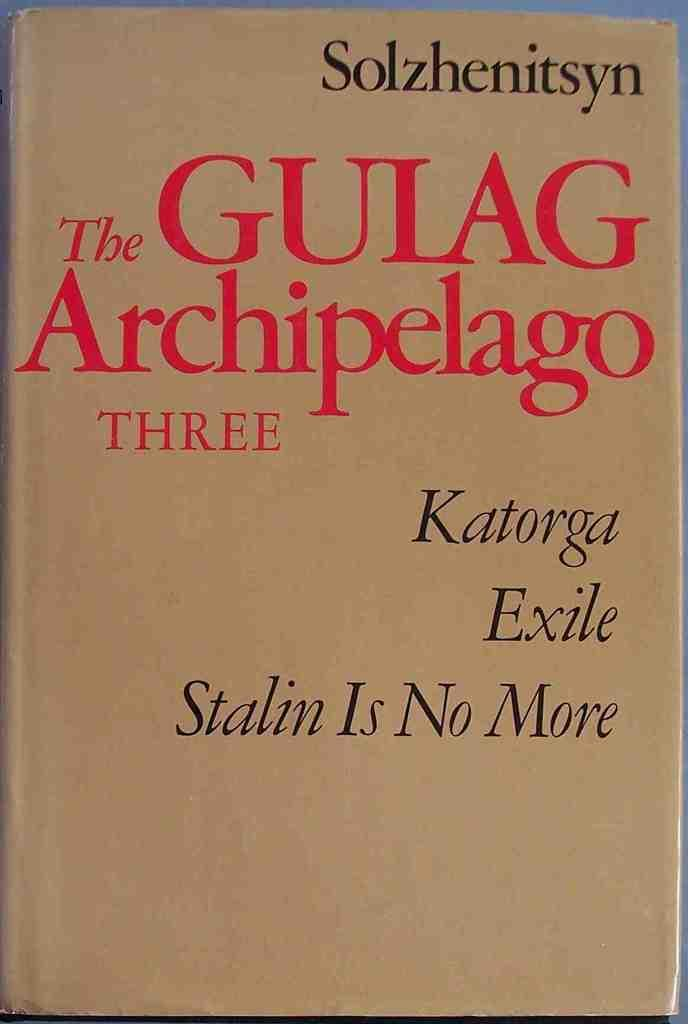<image>
Summarize the visual content of the image. A brown covered book with the title The Gulag Archipelago Three. 